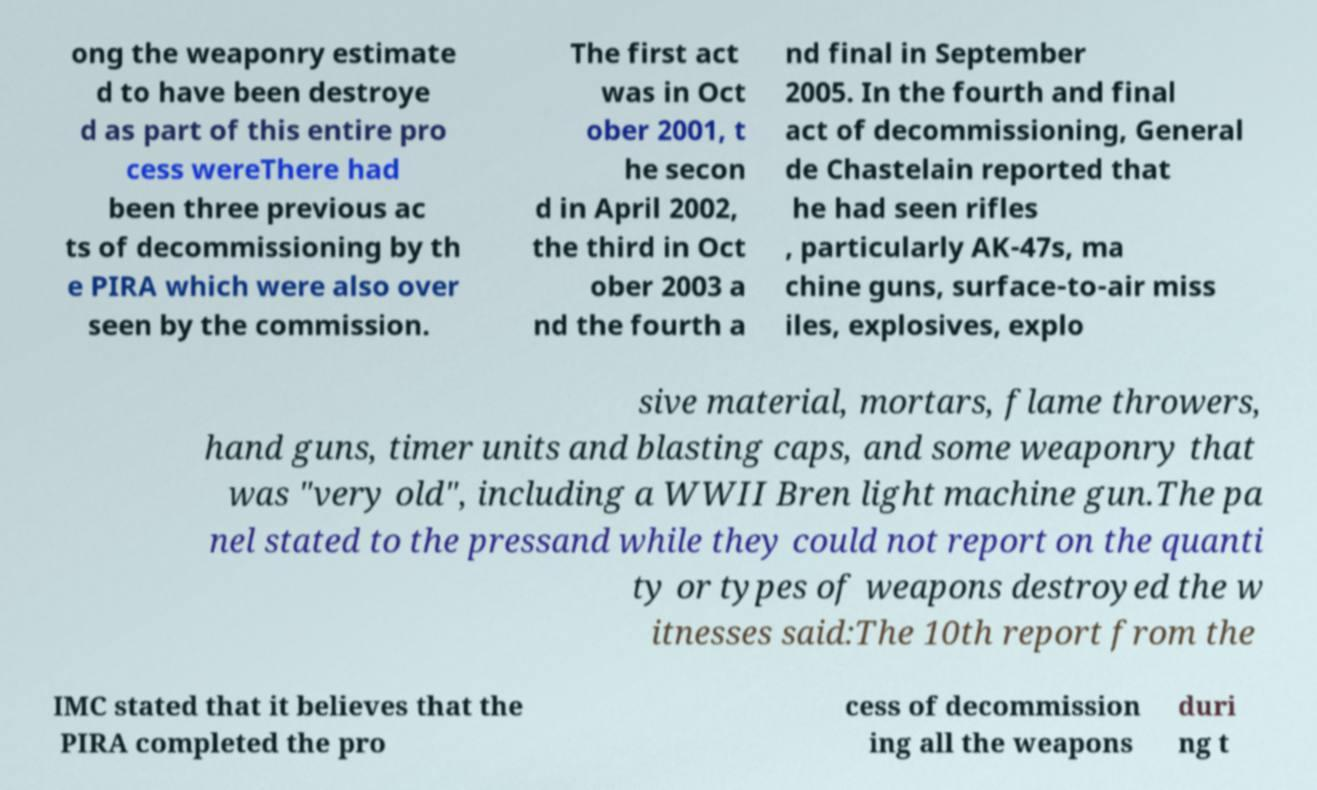Could you extract and type out the text from this image? ong the weaponry estimate d to have been destroye d as part of this entire pro cess wereThere had been three previous ac ts of decommissioning by th e PIRA which were also over seen by the commission. The first act was in Oct ober 2001, t he secon d in April 2002, the third in Oct ober 2003 a nd the fourth a nd final in September 2005. In the fourth and final act of decommissioning, General de Chastelain reported that he had seen rifles , particularly AK-47s, ma chine guns, surface-to-air miss iles, explosives, explo sive material, mortars, flame throwers, hand guns, timer units and blasting caps, and some weaponry that was "very old", including a WWII Bren light machine gun.The pa nel stated to the pressand while they could not report on the quanti ty or types of weapons destroyed the w itnesses said:The 10th report from the IMC stated that it believes that the PIRA completed the pro cess of decommission ing all the weapons duri ng t 